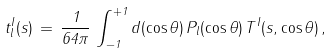<formula> <loc_0><loc_0><loc_500><loc_500>t _ { l } ^ { I } ( s ) \, = \, \frac { 1 } { 6 4 \pi } \, \int _ { - 1 } ^ { + 1 } d ( \cos \theta ) \, P _ { l } ( \cos \theta ) \, T ^ { I } ( s , \cos \theta ) \, ,</formula> 